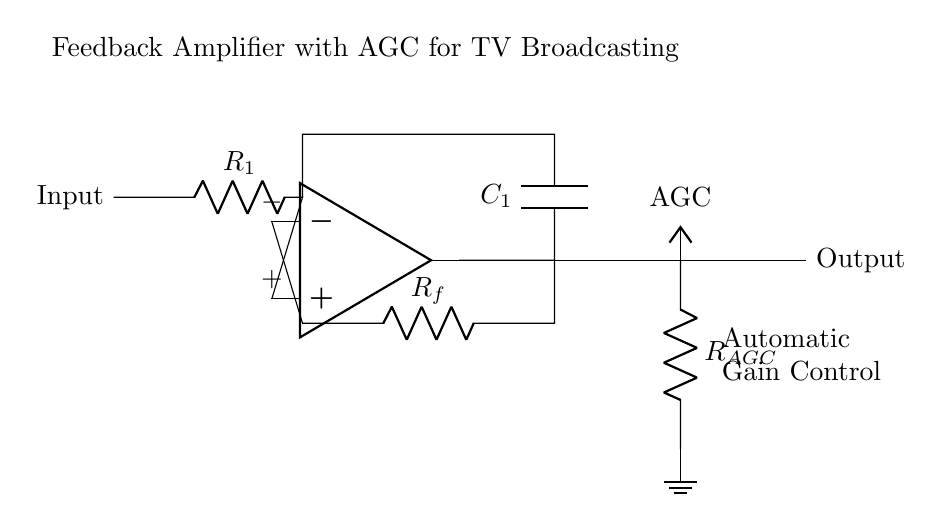What type of amplifier is this circuit? The circuit is focused on feedback amplification with automatic gain control (AGC), indicating that it is a feedback amplifier.
Answer: feedback amplifier What component provides the feedback in this circuit? The resistor labeled R_f is the component that provides feedback from the output to the inverting terminal of the operational amplifier.
Answer: R_f What is the function of the capacitor in this circuit? The capacitor labeled C_1 serves to couple AC signals, allowing AC components to pass while blocking DC components, which is important for signal integrity in broadcasting.
Answer: AC coupling What does AGC stand for in this circuit? AGC stands for Automatic Gain Control, which is a feature to automatically adjust the gain of the amplifier based on the input signal level.
Answer: Automatic Gain Control Which component is connected to the non-inverting terminal of the amplifier? The input signal, through resistor R_1, is connected to the non-inverting terminal of the operational amplifier in this configuration.
Answer: R_1 How does the circuit achieve gain control? Gain control is achieved through the feedback resistor R_f and the resistor for AGC, allowing the amplifier to adjust the gain based on the output signal level dynamically.
Answer: Feedback network What is the purpose of the ground connection in this circuit? The ground connection provides a reference point for the circuit, ensuring that all voltage levels are measured with respect to ground, which is essential for the operation of the amplifier.
Answer: Reference point 